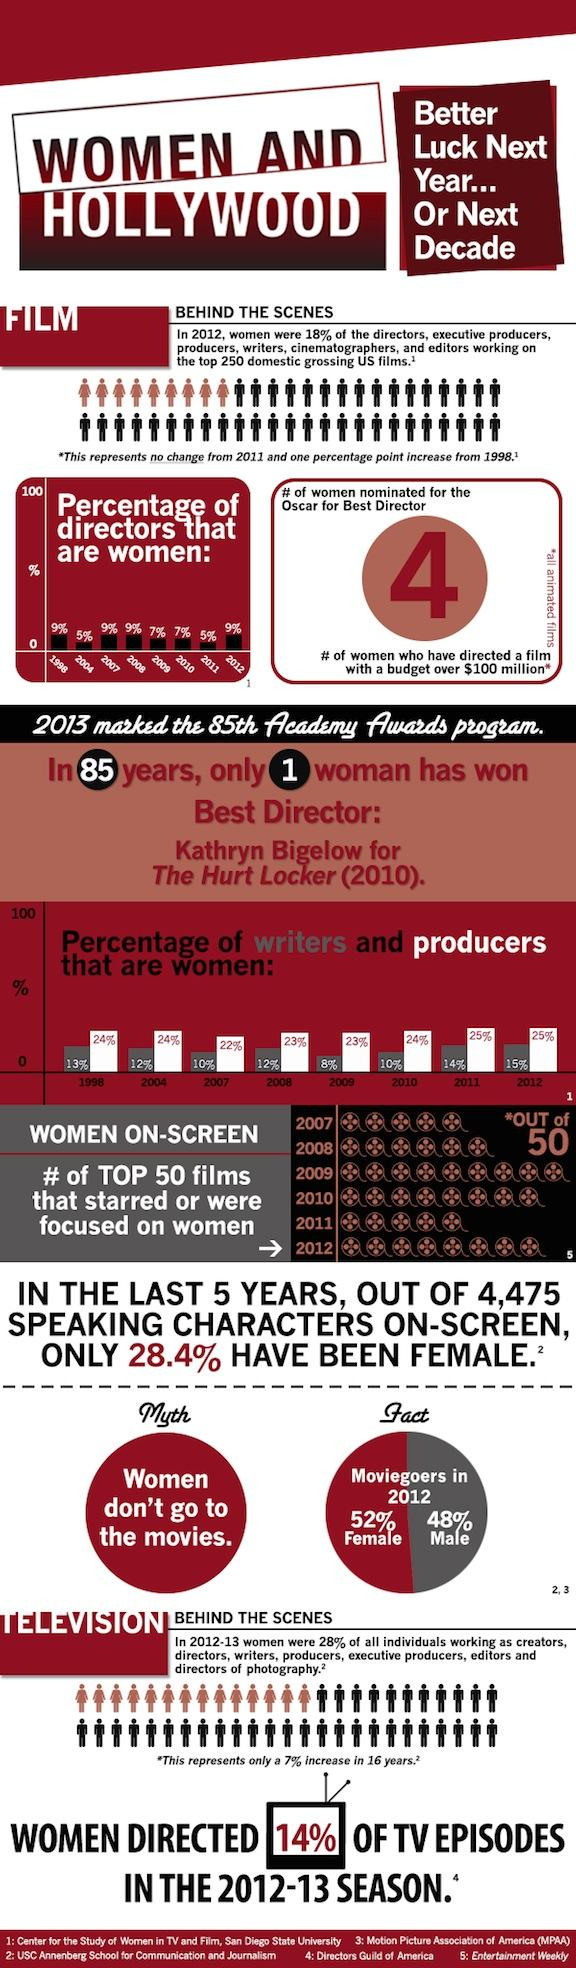Give some essential details in this illustration. In 2008, only 12% of writers in the U.S. film industry were women. In 2010, only 7% of directors in Hollywood were women. In the year 2012, four women were nominated for the Oscar in the category of best director. Of the top 50 films in 2011, only 5 of them starred or focused on women. Kathryn Bigelow is the first woman to win an Academy Award for Best Director. 